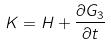Convert formula to latex. <formula><loc_0><loc_0><loc_500><loc_500>K = H + \frac { \partial G _ { 3 } } { \partial t }</formula> 